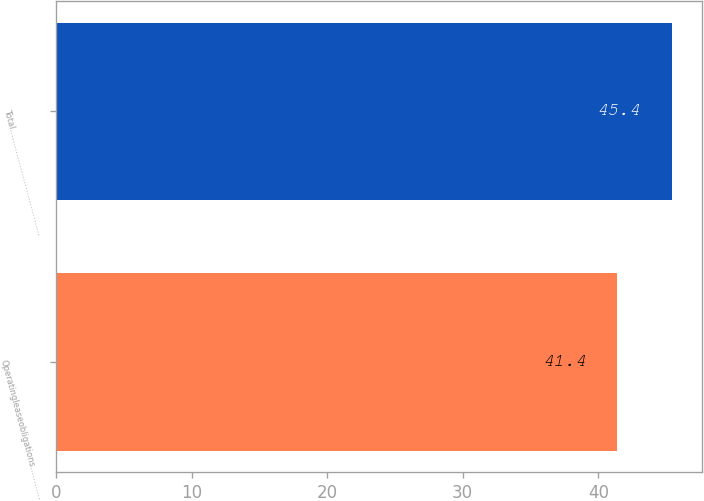Convert chart. <chart><loc_0><loc_0><loc_500><loc_500><bar_chart><fcel>Operatingleaseobligations…………<fcel>Total…………………………………<nl><fcel>41.4<fcel>45.4<nl></chart> 